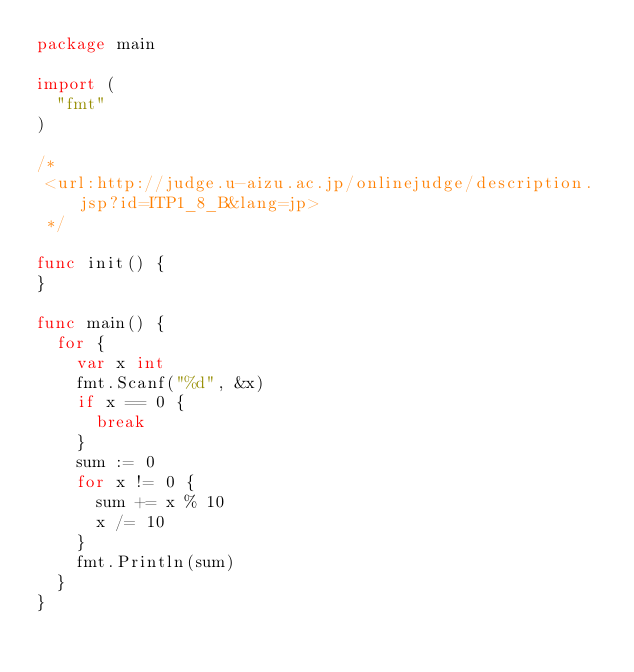Convert code to text. <code><loc_0><loc_0><loc_500><loc_500><_Go_>package main

import (
	"fmt"
)

/*
 <url:http://judge.u-aizu.ac.jp/onlinejudge/description.jsp?id=ITP1_8_B&lang=jp>
 */

func init() {
}

func main() {
	for {
		var x int
		fmt.Scanf("%d", &x)
		if x == 0 {
			break
		}
		sum := 0
		for x != 0 {
			sum += x % 10
			x /= 10
		}
		fmt.Println(sum)
	}
}</code> 